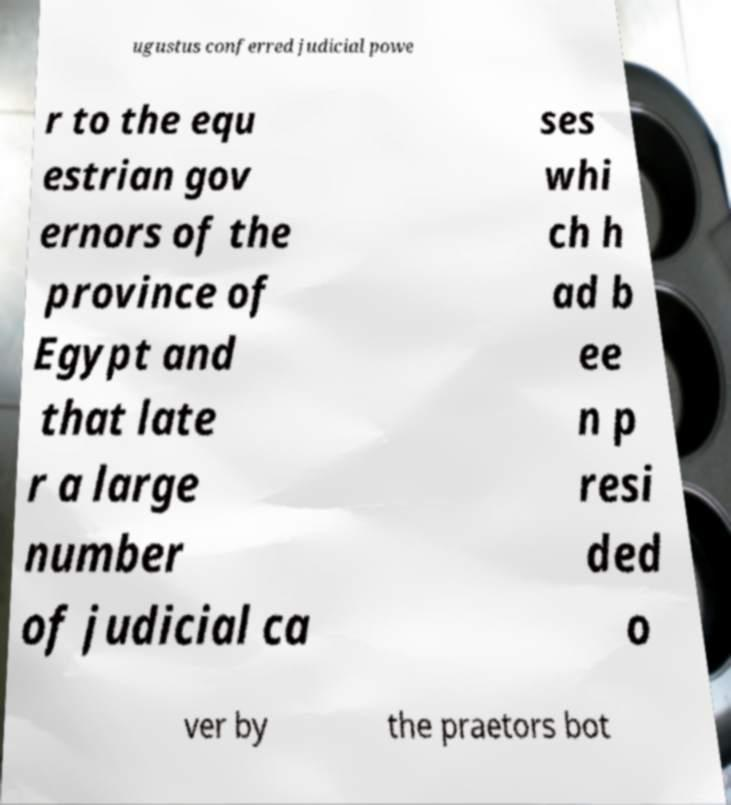Could you extract and type out the text from this image? ugustus conferred judicial powe r to the equ estrian gov ernors of the province of Egypt and that late r a large number of judicial ca ses whi ch h ad b ee n p resi ded o ver by the praetors bot 